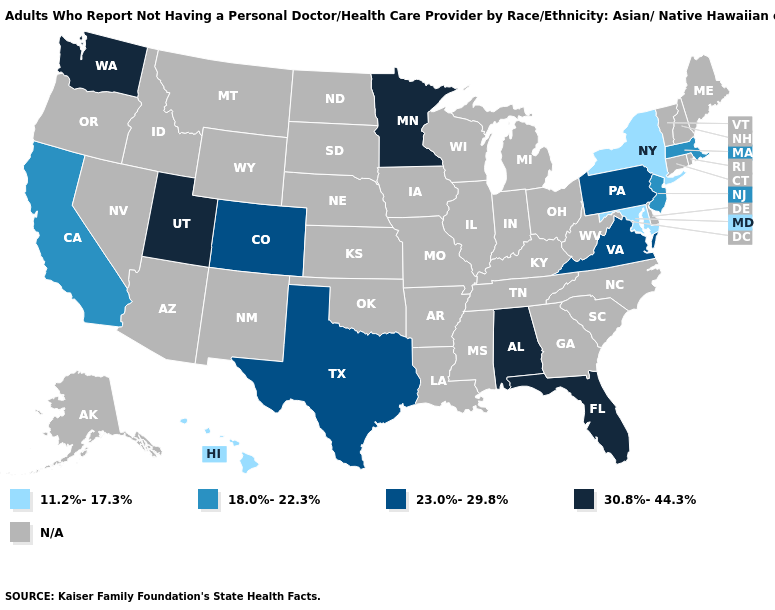What is the value of New Mexico?
Short answer required. N/A. Does the map have missing data?
Short answer required. Yes. What is the value of New Mexico?
Write a very short answer. N/A. Which states have the lowest value in the USA?
Short answer required. Hawaii, Maryland, New York. Name the states that have a value in the range 18.0%-22.3%?
Keep it brief. California, Massachusetts, New Jersey. Which states have the lowest value in the USA?
Quick response, please. Hawaii, Maryland, New York. Name the states that have a value in the range N/A?
Keep it brief. Alaska, Arizona, Arkansas, Connecticut, Delaware, Georgia, Idaho, Illinois, Indiana, Iowa, Kansas, Kentucky, Louisiana, Maine, Michigan, Mississippi, Missouri, Montana, Nebraska, Nevada, New Hampshire, New Mexico, North Carolina, North Dakota, Ohio, Oklahoma, Oregon, Rhode Island, South Carolina, South Dakota, Tennessee, Vermont, West Virginia, Wisconsin, Wyoming. What is the value of Montana?
Answer briefly. N/A. What is the highest value in the MidWest ?
Short answer required. 30.8%-44.3%. What is the value of New Jersey?
Give a very brief answer. 18.0%-22.3%. 